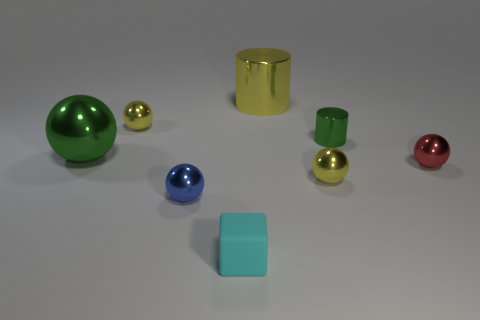How many yellow spheres must be subtracted to get 1 yellow spheres? 1 Subtract all red spheres. How many spheres are left? 4 Subtract all red balls. How many balls are left? 4 Subtract all brown spheres. Subtract all cyan cubes. How many spheres are left? 5 Add 2 tiny shiny objects. How many objects exist? 10 Subtract all spheres. How many objects are left? 3 Add 1 large gray rubber cylinders. How many large gray rubber cylinders exist? 1 Subtract 0 red cubes. How many objects are left? 8 Subtract all cyan blocks. Subtract all tiny yellow metallic balls. How many objects are left? 5 Add 5 red spheres. How many red spheres are left? 6 